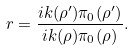Convert formula to latex. <formula><loc_0><loc_0><loc_500><loc_500>r = \frac { \L i k ( \rho ^ { \prime } ) \pi _ { 0 } ( \rho ^ { \prime } ) } { \L i k ( \rho ) \pi _ { 0 } ( \rho ) } .</formula> 